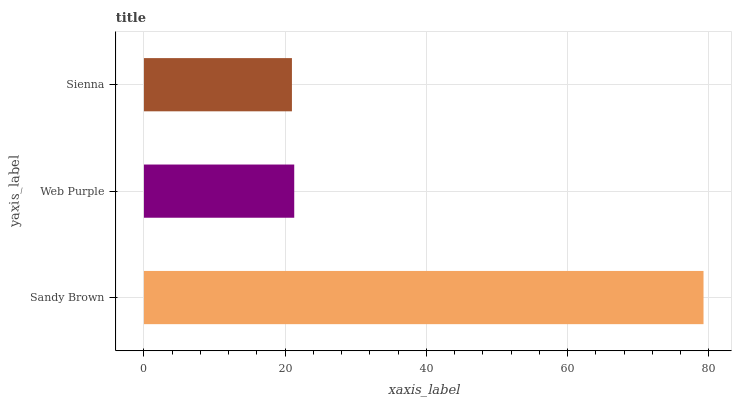Is Sienna the minimum?
Answer yes or no. Yes. Is Sandy Brown the maximum?
Answer yes or no. Yes. Is Web Purple the minimum?
Answer yes or no. No. Is Web Purple the maximum?
Answer yes or no. No. Is Sandy Brown greater than Web Purple?
Answer yes or no. Yes. Is Web Purple less than Sandy Brown?
Answer yes or no. Yes. Is Web Purple greater than Sandy Brown?
Answer yes or no. No. Is Sandy Brown less than Web Purple?
Answer yes or no. No. Is Web Purple the high median?
Answer yes or no. Yes. Is Web Purple the low median?
Answer yes or no. Yes. Is Sandy Brown the high median?
Answer yes or no. No. Is Sandy Brown the low median?
Answer yes or no. No. 